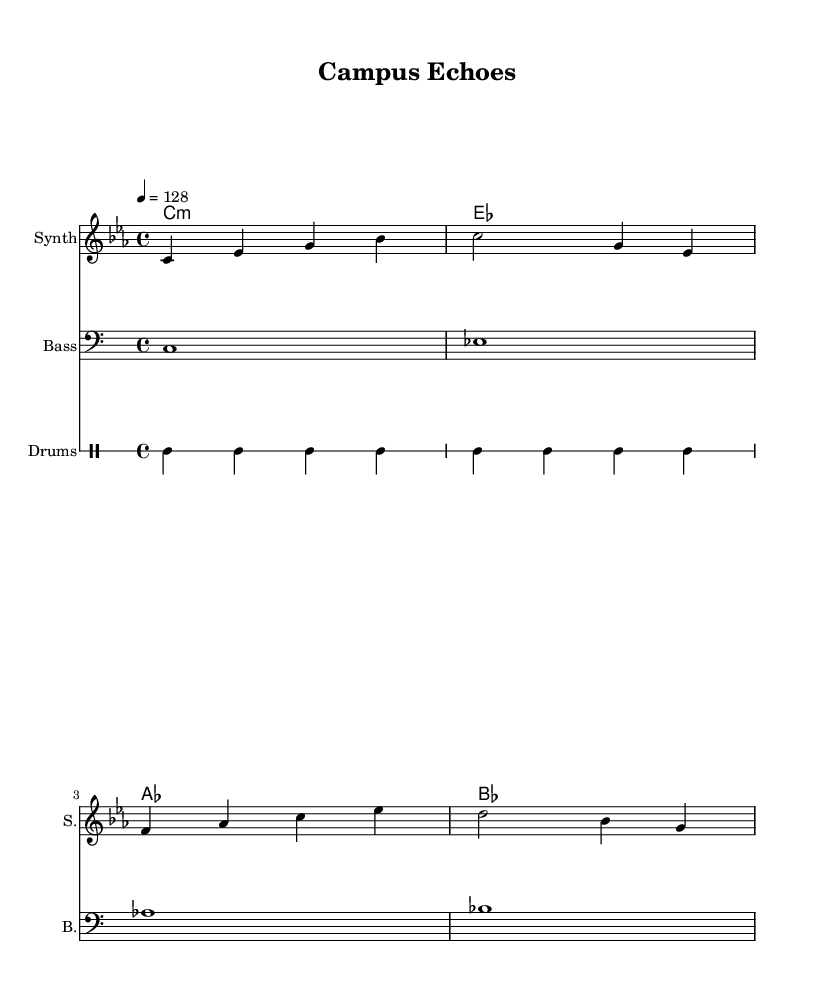What is the key signature of this music? The key signature is indicated by the number of sharps or flats at the beginning of the staff. In this sheet music, there are no sharps or flats shown, which indicates it is in C minor, as C minor has three flats in its key signature (B flat, E flat, and A flat), and the absence of these symbols signifies its tonic and relative major.
Answer: C minor What is the time signature of this music? The time signature is found at the beginning of the sheet music and indicates the number of beats in each measure. In this case, the "4/4" displayed indicates that there are four beats per measure and the quarter note gets one beat.
Answer: 4/4 What is the tempo marking of this music? The tempo marking is indicated by the number and note that specify the speed of the piece. Here, "4 = 128" suggests that there are 128 beats per minute, indicating a moderate tempo typical for house music.
Answer: 128 How many measures are in the melody? By counting the bar lines present in the melody staff, we can determine the number of measures. There are five measure divisions within the melody line, each separated by bar lines.
Answer: 5 What instruments are featured in this piece? The instruments are indicated by their names at the beginning of each staff. Here we see "Synth," "Bass," and "Drums" listed, representing the various elements contributing to the atmospheric house music.
Answer: Synth, Bass, Drums What type of chords are used in the harmony section? The chord designation found in the harmony section indicates the type of chords used in the piece. The presence of "c1:m," "es," "as," and "bes" suggests that these chords are primarily minor and major chords, common in house music for creating depth and atmosphere.
Answer: Major and minor chords What is the rhythmic pattern used for the drums? The rhythmic pattern for the drums can be seen in the drummode section. The consistency of "bd," "hh," and "sn" indicates that a bass drum, hi-hat, and snare drum are played in a repeated pattern, typical for driving house beats.
Answer: Bass, Hi-hat, Snare 